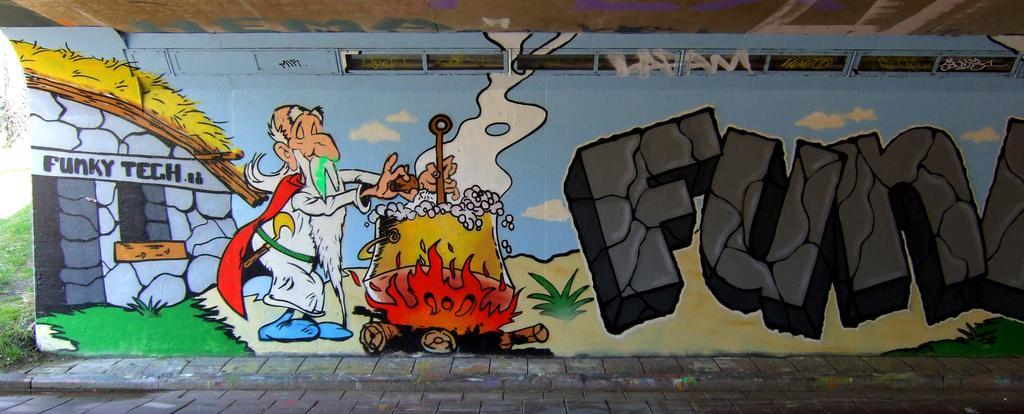In one or two sentences, can you explain what this image depicts? In this image there is a wall. There are paintings and text on the wall. To the right there is text on the wall. To the left there is picture of a person and he is cooking. To the left there's grass on the ground. 